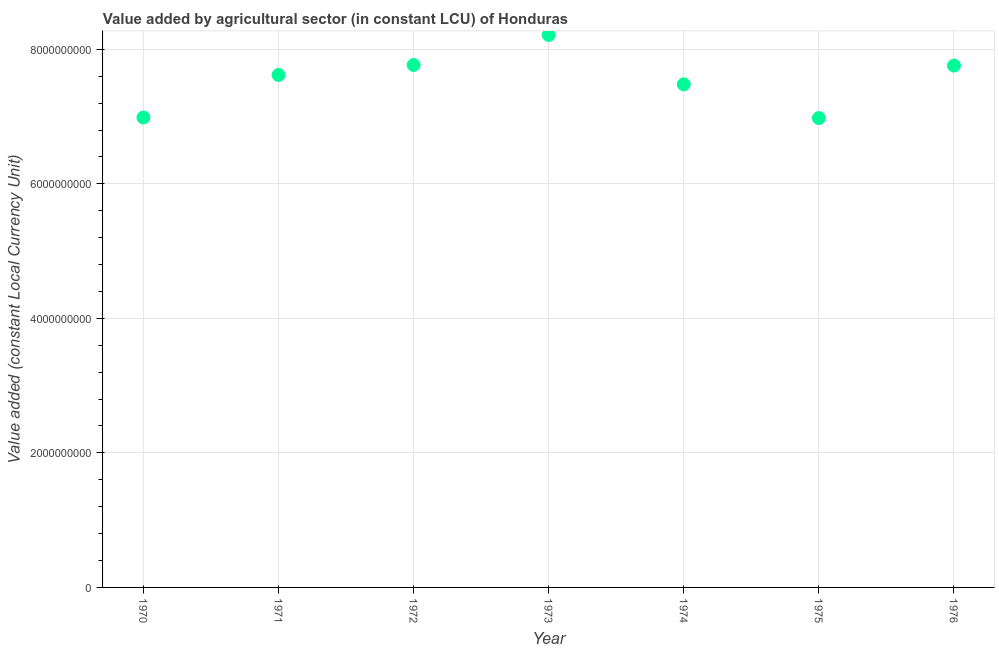What is the value added by agriculture sector in 1976?
Ensure brevity in your answer.  7.76e+09. Across all years, what is the maximum value added by agriculture sector?
Give a very brief answer. 8.21e+09. Across all years, what is the minimum value added by agriculture sector?
Your answer should be compact. 6.98e+09. In which year was the value added by agriculture sector maximum?
Make the answer very short. 1973. In which year was the value added by agriculture sector minimum?
Offer a very short reply. 1975. What is the sum of the value added by agriculture sector?
Your answer should be very brief. 5.28e+1. What is the difference between the value added by agriculture sector in 1970 and 1974?
Offer a very short reply. -4.92e+08. What is the average value added by agriculture sector per year?
Your answer should be very brief. 7.54e+09. What is the median value added by agriculture sector?
Offer a very short reply. 7.62e+09. What is the ratio of the value added by agriculture sector in 1971 to that in 1972?
Make the answer very short. 0.98. Is the difference between the value added by agriculture sector in 1973 and 1975 greater than the difference between any two years?
Provide a succinct answer. Yes. What is the difference between the highest and the second highest value added by agriculture sector?
Give a very brief answer. 4.46e+08. What is the difference between the highest and the lowest value added by agriculture sector?
Offer a very short reply. 1.24e+09. In how many years, is the value added by agriculture sector greater than the average value added by agriculture sector taken over all years?
Provide a succinct answer. 4. How many years are there in the graph?
Provide a succinct answer. 7. What is the difference between two consecutive major ticks on the Y-axis?
Your response must be concise. 2.00e+09. Are the values on the major ticks of Y-axis written in scientific E-notation?
Ensure brevity in your answer.  No. Does the graph contain grids?
Keep it short and to the point. Yes. What is the title of the graph?
Your answer should be compact. Value added by agricultural sector (in constant LCU) of Honduras. What is the label or title of the X-axis?
Offer a terse response. Year. What is the label or title of the Y-axis?
Offer a terse response. Value added (constant Local Currency Unit). What is the Value added (constant Local Currency Unit) in 1970?
Keep it short and to the point. 6.99e+09. What is the Value added (constant Local Currency Unit) in 1971?
Your response must be concise. 7.62e+09. What is the Value added (constant Local Currency Unit) in 1972?
Make the answer very short. 7.77e+09. What is the Value added (constant Local Currency Unit) in 1973?
Your response must be concise. 8.21e+09. What is the Value added (constant Local Currency Unit) in 1974?
Your answer should be compact. 7.48e+09. What is the Value added (constant Local Currency Unit) in 1975?
Your response must be concise. 6.98e+09. What is the Value added (constant Local Currency Unit) in 1976?
Your answer should be compact. 7.76e+09. What is the difference between the Value added (constant Local Currency Unit) in 1970 and 1971?
Make the answer very short. -6.32e+08. What is the difference between the Value added (constant Local Currency Unit) in 1970 and 1972?
Provide a short and direct response. -7.80e+08. What is the difference between the Value added (constant Local Currency Unit) in 1970 and 1973?
Provide a succinct answer. -1.23e+09. What is the difference between the Value added (constant Local Currency Unit) in 1970 and 1974?
Provide a short and direct response. -4.92e+08. What is the difference between the Value added (constant Local Currency Unit) in 1970 and 1975?
Your answer should be compact. 9.29e+06. What is the difference between the Value added (constant Local Currency Unit) in 1970 and 1976?
Provide a succinct answer. -7.71e+08. What is the difference between the Value added (constant Local Currency Unit) in 1971 and 1972?
Provide a short and direct response. -1.49e+08. What is the difference between the Value added (constant Local Currency Unit) in 1971 and 1973?
Provide a short and direct response. -5.95e+08. What is the difference between the Value added (constant Local Currency Unit) in 1971 and 1974?
Provide a short and direct response. 1.39e+08. What is the difference between the Value added (constant Local Currency Unit) in 1971 and 1975?
Offer a very short reply. 6.41e+08. What is the difference between the Value added (constant Local Currency Unit) in 1971 and 1976?
Your answer should be compact. -1.39e+08. What is the difference between the Value added (constant Local Currency Unit) in 1972 and 1973?
Provide a short and direct response. -4.46e+08. What is the difference between the Value added (constant Local Currency Unit) in 1972 and 1974?
Keep it short and to the point. 2.88e+08. What is the difference between the Value added (constant Local Currency Unit) in 1972 and 1975?
Give a very brief answer. 7.90e+08. What is the difference between the Value added (constant Local Currency Unit) in 1972 and 1976?
Make the answer very short. 9.29e+06. What is the difference between the Value added (constant Local Currency Unit) in 1973 and 1974?
Make the answer very short. 7.34e+08. What is the difference between the Value added (constant Local Currency Unit) in 1973 and 1975?
Give a very brief answer. 1.24e+09. What is the difference between the Value added (constant Local Currency Unit) in 1973 and 1976?
Give a very brief answer. 4.55e+08. What is the difference between the Value added (constant Local Currency Unit) in 1974 and 1975?
Your answer should be very brief. 5.02e+08. What is the difference between the Value added (constant Local Currency Unit) in 1974 and 1976?
Your answer should be very brief. -2.79e+08. What is the difference between the Value added (constant Local Currency Unit) in 1975 and 1976?
Ensure brevity in your answer.  -7.80e+08. What is the ratio of the Value added (constant Local Currency Unit) in 1970 to that in 1971?
Provide a succinct answer. 0.92. What is the ratio of the Value added (constant Local Currency Unit) in 1970 to that in 1973?
Your answer should be very brief. 0.85. What is the ratio of the Value added (constant Local Currency Unit) in 1970 to that in 1974?
Keep it short and to the point. 0.93. What is the ratio of the Value added (constant Local Currency Unit) in 1970 to that in 1976?
Offer a terse response. 0.9. What is the ratio of the Value added (constant Local Currency Unit) in 1971 to that in 1973?
Your answer should be very brief. 0.93. What is the ratio of the Value added (constant Local Currency Unit) in 1971 to that in 1975?
Provide a succinct answer. 1.09. What is the ratio of the Value added (constant Local Currency Unit) in 1972 to that in 1973?
Make the answer very short. 0.95. What is the ratio of the Value added (constant Local Currency Unit) in 1972 to that in 1974?
Your answer should be compact. 1.04. What is the ratio of the Value added (constant Local Currency Unit) in 1972 to that in 1975?
Make the answer very short. 1.11. What is the ratio of the Value added (constant Local Currency Unit) in 1973 to that in 1974?
Give a very brief answer. 1.1. What is the ratio of the Value added (constant Local Currency Unit) in 1973 to that in 1975?
Offer a very short reply. 1.18. What is the ratio of the Value added (constant Local Currency Unit) in 1973 to that in 1976?
Make the answer very short. 1.06. What is the ratio of the Value added (constant Local Currency Unit) in 1974 to that in 1975?
Your answer should be very brief. 1.07. What is the ratio of the Value added (constant Local Currency Unit) in 1974 to that in 1976?
Keep it short and to the point. 0.96. What is the ratio of the Value added (constant Local Currency Unit) in 1975 to that in 1976?
Keep it short and to the point. 0.9. 